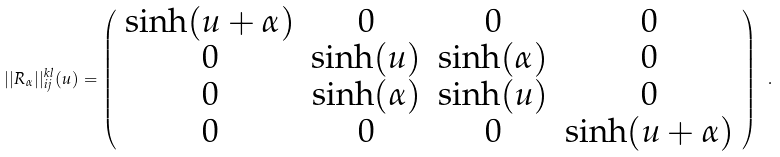Convert formula to latex. <formula><loc_0><loc_0><loc_500><loc_500>| | R _ { \alpha } | | _ { i j } ^ { k l } ( u ) = \left ( \begin{array} { c c c c } \sinh ( u + \alpha ) & 0 & 0 & 0 \\ 0 & \sinh ( u ) & \sinh ( \alpha ) & 0 \\ 0 & \sinh ( \alpha ) & \sinh ( u ) & 0 \\ 0 & 0 & 0 & \sinh ( u + \alpha ) \end{array} \right ) \ .</formula> 